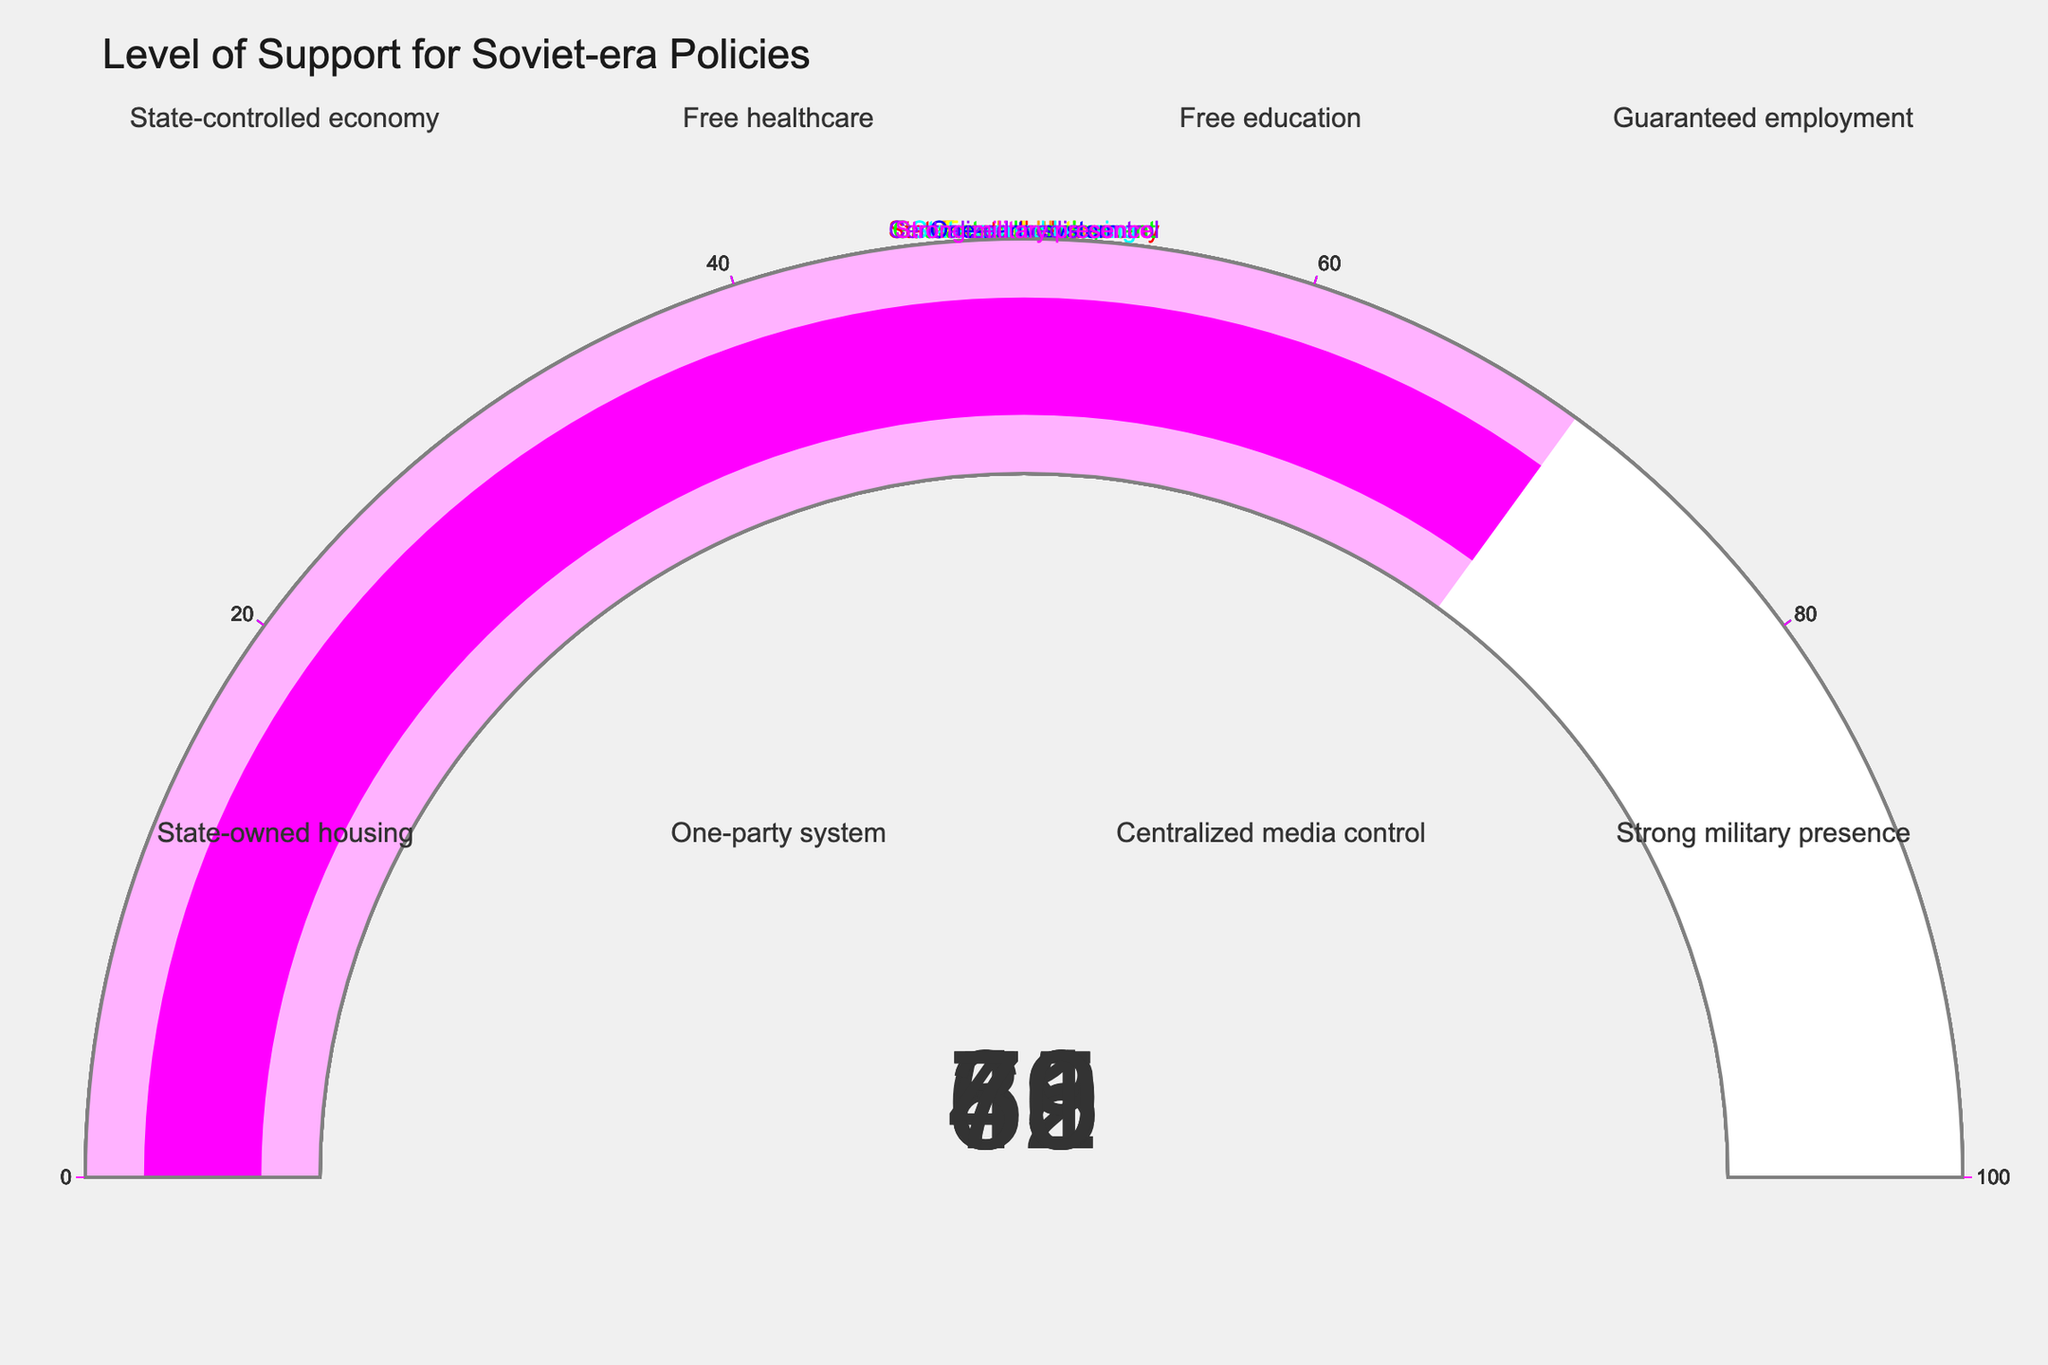What is the title of the Gauge Chart? The title of the chart is located at the top and represents the main topic of the visualization. From the context, the title should convey the main idea of the data being presented.
Answer: Level of Support for Soviet-era Policies What is the highest value of support shown in the chart? To find the highest value, look for the gauge with the highest number displayed.
Answer: 85% What percentage of citizens support a state-controlled economy? This can be found by locating the gauge corresponding to "State-controlled economy" and reading the value displayed.
Answer: 62% Which policy has the lowest level of support among the citizens? To determine this, identify the gauge with the smallest number displayed.
Answer: Centralized media control How many policies have a support level above 70%? Count the number of gauges that display a percentage higher than 70%.
Answer: 3 What is the average support percentage of the policies "Free healthcare" and "Free education"? Sum the values of "Free healthcare" (85) and "Free education" (79), then divide by 2 to get the average.
Answer: 82% What is the difference in support between "Strong military presence" and "State-owned housing"? Subtract the support percentage of "State-owned housing" (45) from that of "Strong military presence" (70).
Answer: 25% Are there more policies with support above 50% or below 50%? Compare the number of gauges with values above 50% versus those with values below 50%.
Answer: Above 50% Which policies have a support level between 30% and 60%? Identify and list the policies whose support values fall within the range of 30% to 60%.
Answer: State-controlled economy, Guaranteed employment, State-owned housing, One-party system, Centralized media control How does the support for a one-party system compare to that for guaranteed employment? Compare the support percentages between "One-party system" (39) and "Guaranteed employment" (58).
Answer: Less 